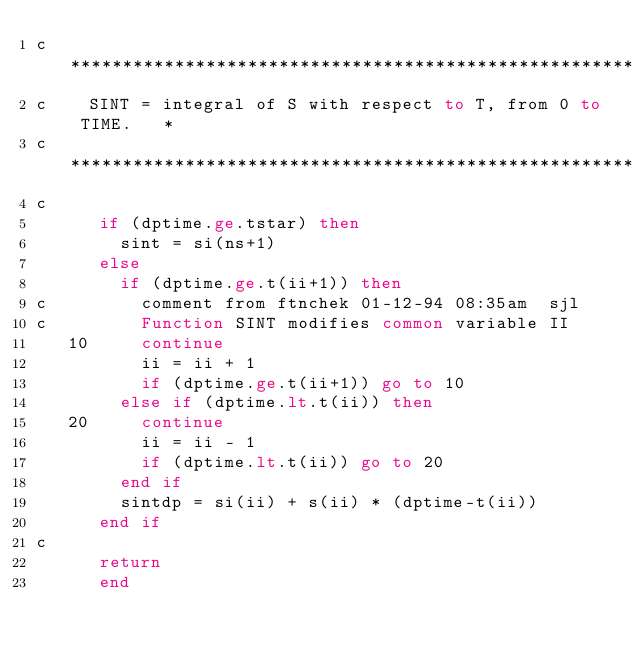<code> <loc_0><loc_0><loc_500><loc_500><_FORTRAN_>c***************************************************************
c    SINT = integral of S with respect to T, from 0 to TIME.   *
c***************************************************************
c
      if (dptime.ge.tstar) then
        sint = si(ns+1)
      else
        if (dptime.ge.t(ii+1)) then
c         comment from ftnchek 01-12-94 08:35am  sjl
c         Function SINT modifies common variable II
   10     continue
          ii = ii + 1
          if (dptime.ge.t(ii+1)) go to 10
        else if (dptime.lt.t(ii)) then
   20     continue
          ii = ii - 1
          if (dptime.lt.t(ii)) go to 20
        end if
        sintdp = si(ii) + s(ii) * (dptime-t(ii))
      end if
c
      return
      end
</code> 